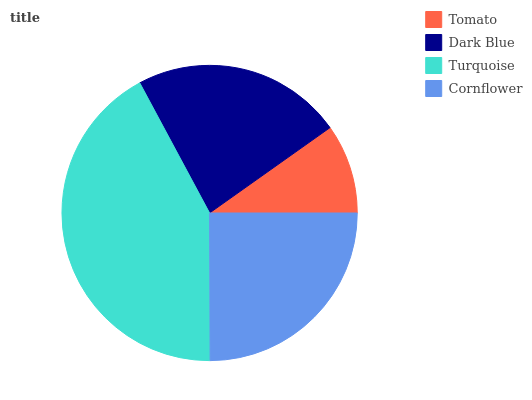Is Tomato the minimum?
Answer yes or no. Yes. Is Turquoise the maximum?
Answer yes or no. Yes. Is Dark Blue the minimum?
Answer yes or no. No. Is Dark Blue the maximum?
Answer yes or no. No. Is Dark Blue greater than Tomato?
Answer yes or no. Yes. Is Tomato less than Dark Blue?
Answer yes or no. Yes. Is Tomato greater than Dark Blue?
Answer yes or no. No. Is Dark Blue less than Tomato?
Answer yes or no. No. Is Cornflower the high median?
Answer yes or no. Yes. Is Dark Blue the low median?
Answer yes or no. Yes. Is Turquoise the high median?
Answer yes or no. No. Is Tomato the low median?
Answer yes or no. No. 